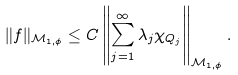<formula> <loc_0><loc_0><loc_500><loc_500>\| f \| _ { { \mathcal { M } } _ { 1 , \phi } } \leq C \left \| \sum _ { j = 1 } ^ { \infty } \lambda _ { j } \chi _ { Q _ { j } } \right \| _ { { \mathcal { M } } _ { 1 , \phi } } .</formula> 